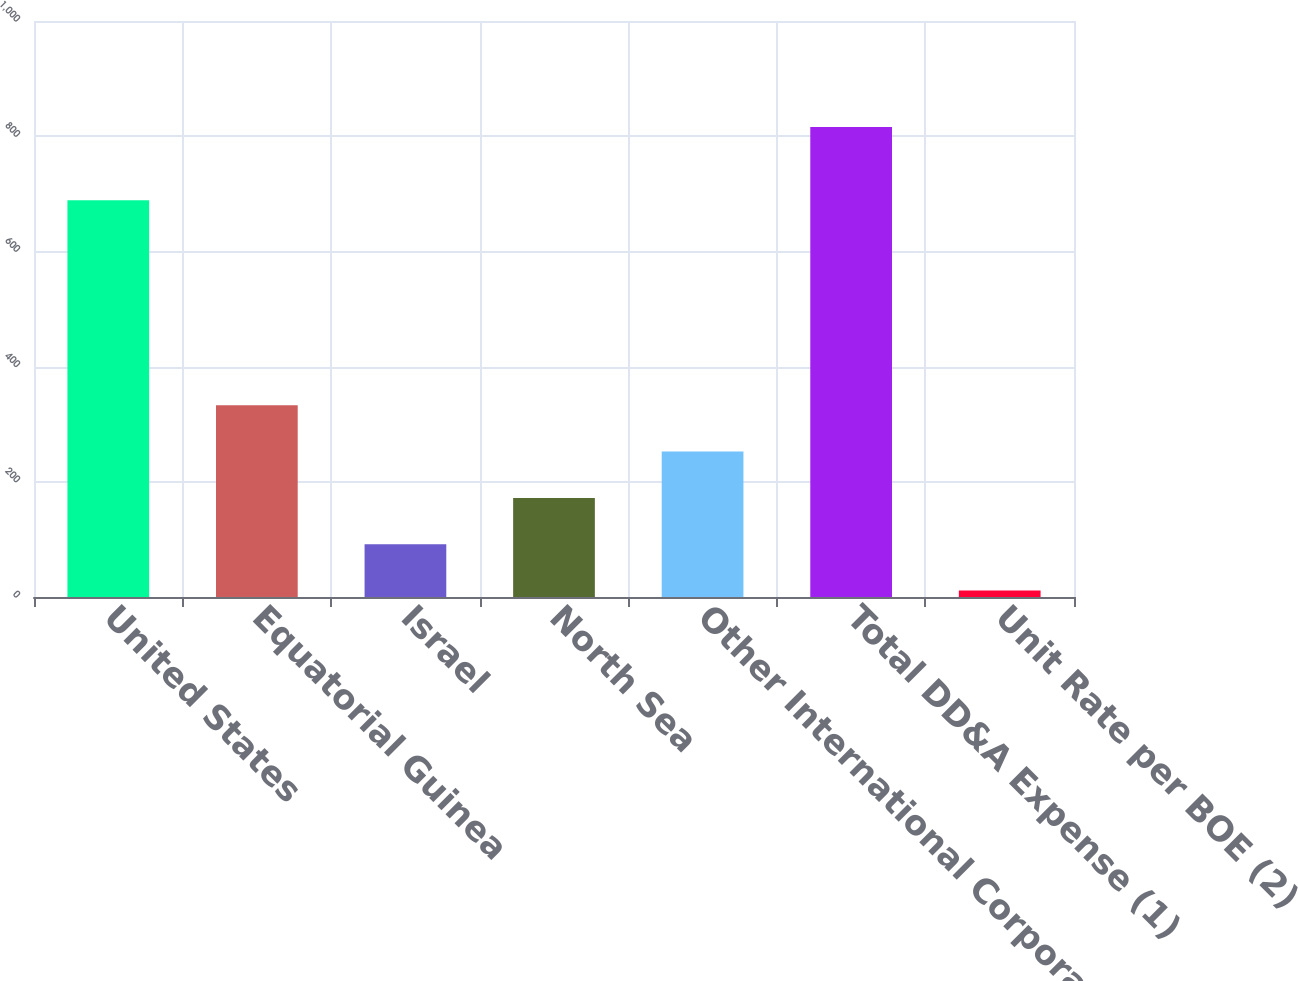Convert chart to OTSL. <chart><loc_0><loc_0><loc_500><loc_500><bar_chart><fcel>United States<fcel>Equatorial Guinea<fcel>Israel<fcel>North Sea<fcel>Other International Corporate<fcel>Total DD&A Expense (1)<fcel>Unit Rate per BOE (2)<nl><fcel>689<fcel>333.04<fcel>91.57<fcel>172.06<fcel>252.55<fcel>816<fcel>11.08<nl></chart> 